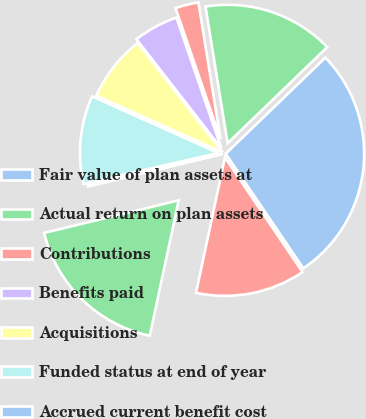Convert chart. <chart><loc_0><loc_0><loc_500><loc_500><pie_chart><fcel>Fair value of plan assets at<fcel>Actual return on plan assets<fcel>Contributions<fcel>Benefits paid<fcel>Acquisitions<fcel>Funded status at end of year<fcel>Accrued current benefit cost<fcel>Accrued noncurrent benefit<fcel>Total<nl><fcel>27.74%<fcel>15.34%<fcel>2.72%<fcel>5.25%<fcel>7.77%<fcel>10.29%<fcel>0.2%<fcel>17.87%<fcel>12.82%<nl></chart> 